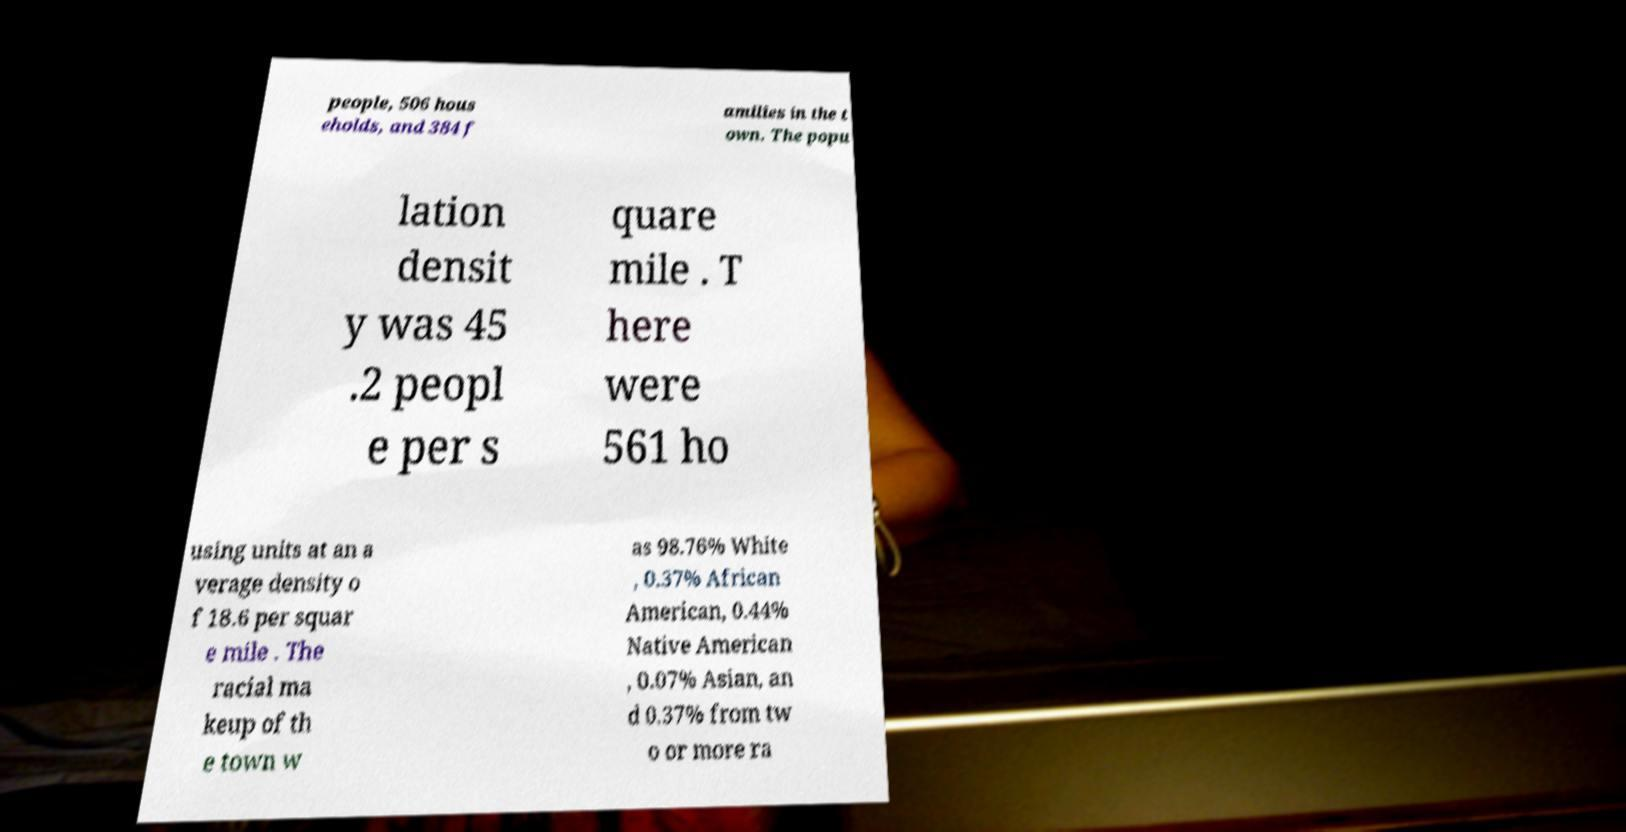I need the written content from this picture converted into text. Can you do that? people, 506 hous eholds, and 384 f amilies in the t own. The popu lation densit y was 45 .2 peopl e per s quare mile . T here were 561 ho using units at an a verage density o f 18.6 per squar e mile . The racial ma keup of th e town w as 98.76% White , 0.37% African American, 0.44% Native American , 0.07% Asian, an d 0.37% from tw o or more ra 